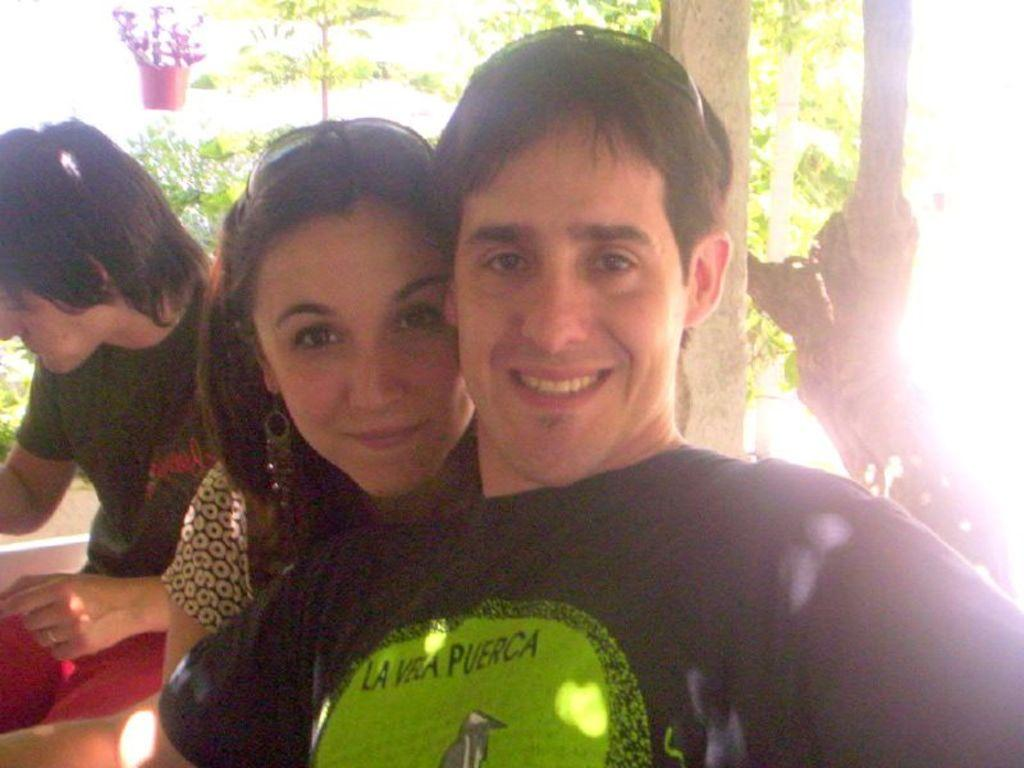How many people are in the image? There are people in the image. What type of natural elements can be seen in the image? There are trees in the image. What else is present in the image besides people and trees? There are objects in the image. Can you describe the expressions of the people in the image? Two people are smiling in the front of the image. What type of feather can be seen floating in the image? There is no feather present in the image. Can you tell me how the steam is being produced in the image? There is no steam present in the image. Who is the manager in the image? There is no mention of a manager in the image. 